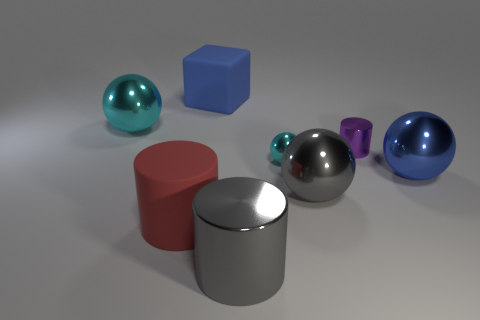What color is the big object that is on the right side of the big red rubber object and on the left side of the gray cylinder?
Provide a succinct answer. Blue. How many cyan metallic objects are right of the big red rubber object?
Offer a terse response. 1. What number of objects are red rubber things or cylinders that are in front of the large red thing?
Ensure brevity in your answer.  2. There is a large ball that is to the right of the small purple object; is there a small metal object behind it?
Offer a terse response. Yes. What color is the big sphere that is on the left side of the big metallic cylinder?
Offer a terse response. Cyan. Is the number of shiny objects right of the large blue rubber cube the same as the number of large metallic spheres?
Offer a terse response. No. There is a large object that is on the right side of the tiny cyan metal thing and on the left side of the big blue shiny thing; what is its shape?
Give a very brief answer. Sphere. The small thing that is the same shape as the big blue shiny object is what color?
Ensure brevity in your answer.  Cyan. Is there any other thing that has the same color as the matte cylinder?
Offer a terse response. No. What is the shape of the large gray thing that is in front of the large red cylinder that is in front of the cyan ball left of the red thing?
Keep it short and to the point. Cylinder. 